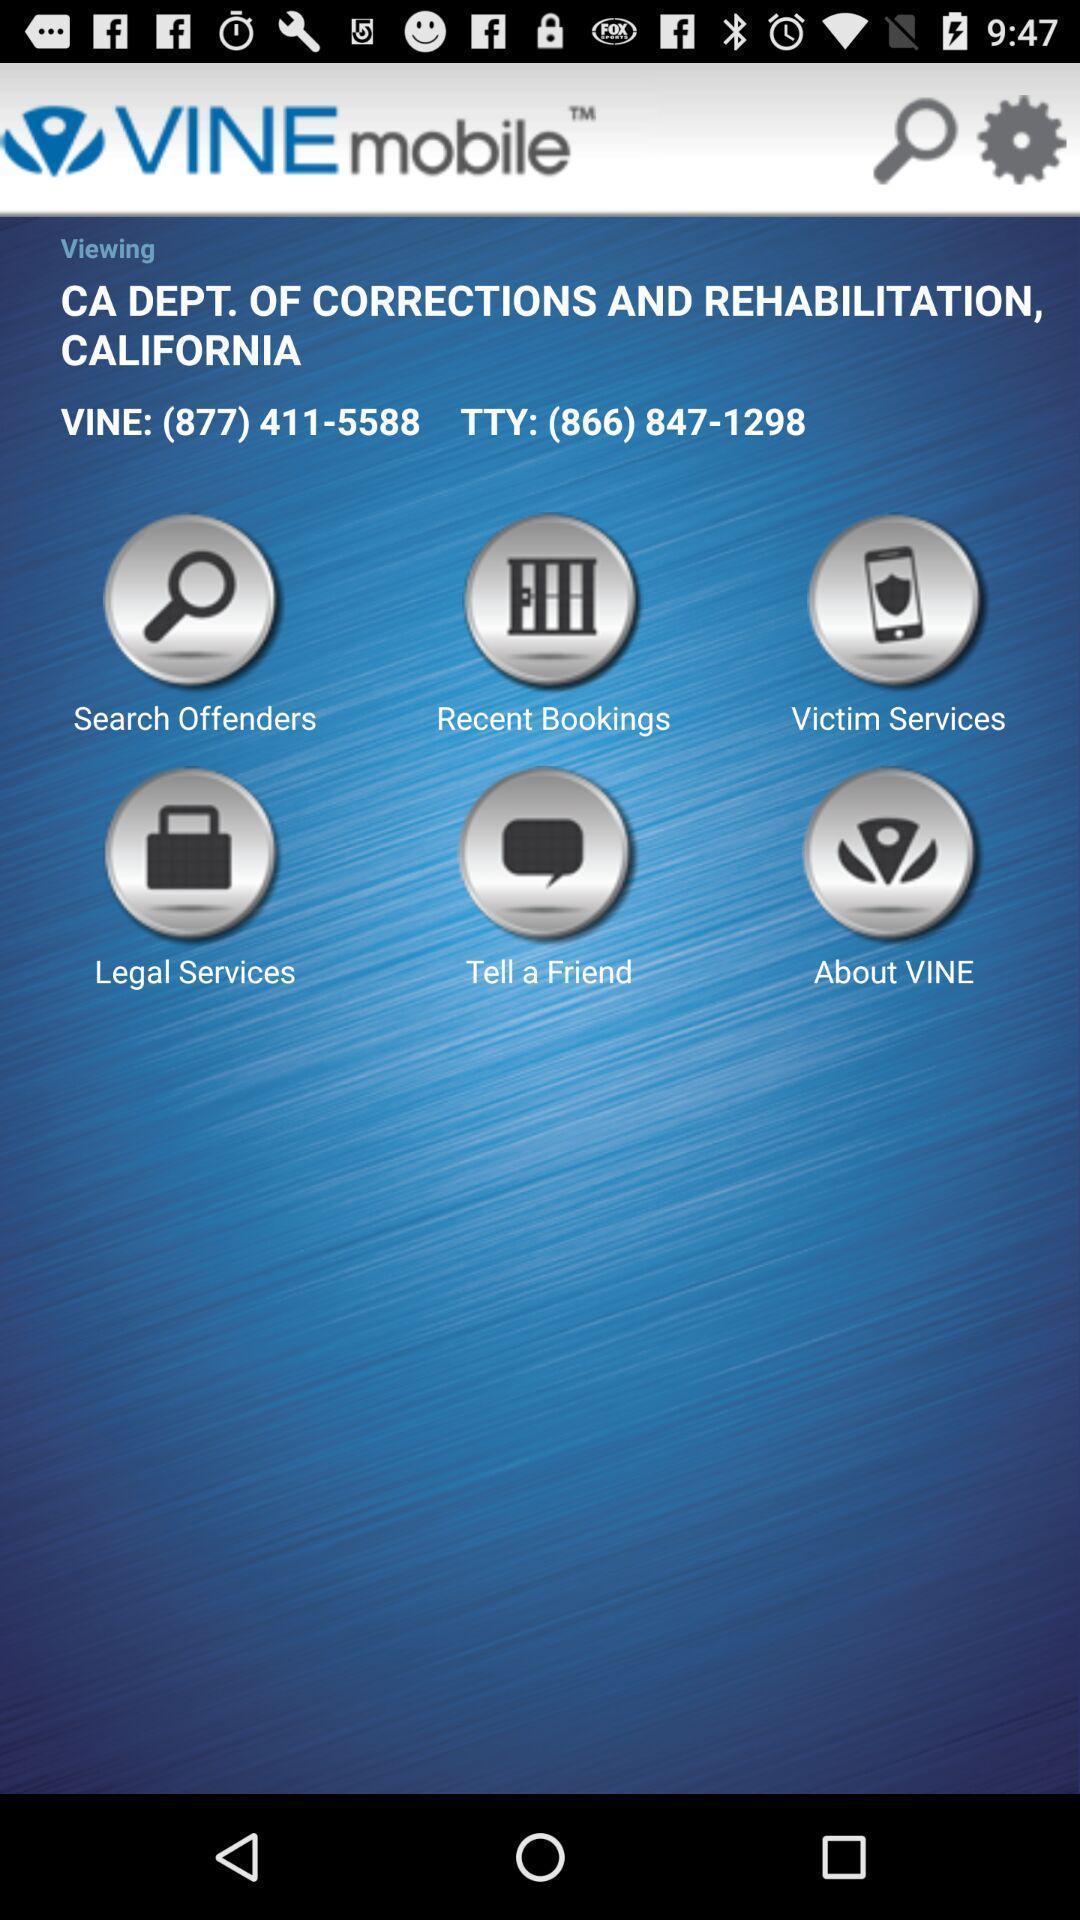Tell me about the visual elements in this screen capture. Page with search booking and services options of citizen service app. 